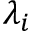<formula> <loc_0><loc_0><loc_500><loc_500>\lambda _ { i }</formula> 